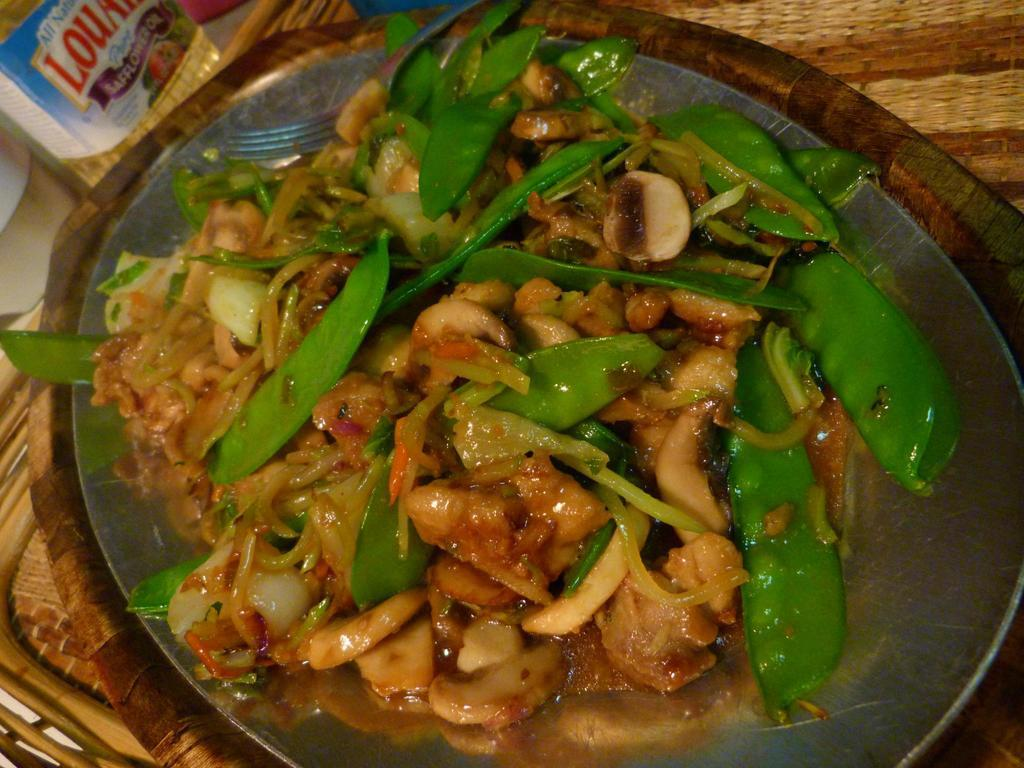What is on the plate in the image? There is food on a plate in the image. What utensil is on the plate? There is a fork on the plate. What type of objects can be seen in the image? There are wooden objects in the image. What can be found in the left side corner of the image? There are unspecified items in the left side corner of the image, and there is also a sticker. How long does it take for the group to finish eating the food in the image? There is no group present in the image, and the time it takes to eat the food cannot be determined from the image alone. 